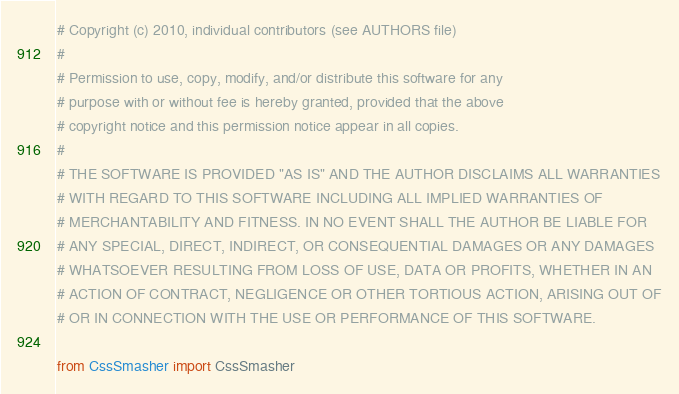<code> <loc_0><loc_0><loc_500><loc_500><_Python_># Copyright (c) 2010, individual contributors (see AUTHORS file)
#
# Permission to use, copy, modify, and/or distribute this software for any
# purpose with or without fee is hereby granted, provided that the above
# copyright notice and this permission notice appear in all copies.
#
# THE SOFTWARE IS PROVIDED "AS IS" AND THE AUTHOR DISCLAIMS ALL WARRANTIES
# WITH REGARD TO THIS SOFTWARE INCLUDING ALL IMPLIED WARRANTIES OF
# MERCHANTABILITY AND FITNESS. IN NO EVENT SHALL THE AUTHOR BE LIABLE FOR
# ANY SPECIAL, DIRECT, INDIRECT, OR CONSEQUENTIAL DAMAGES OR ANY DAMAGES
# WHATSOEVER RESULTING FROM LOSS OF USE, DATA OR PROFITS, WHETHER IN AN
# ACTION OF CONTRACT, NEGLIGENCE OR OTHER TORTIOUS ACTION, ARISING OUT OF
# OR IN CONNECTION WITH THE USE OR PERFORMANCE OF THIS SOFTWARE.

from CssSmasher import CssSmasher</code> 